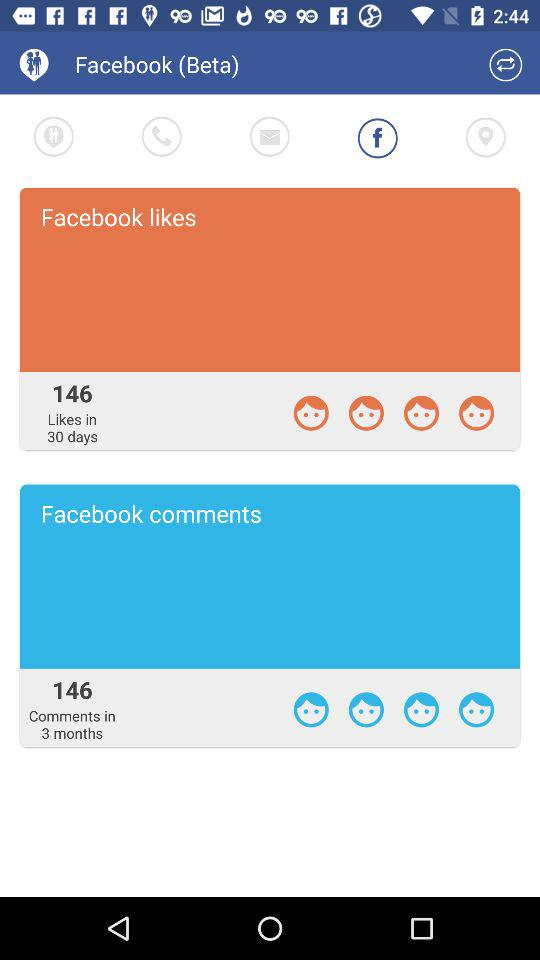How many "Facebook" comments are there? There are 146 "Facebook" comments. 